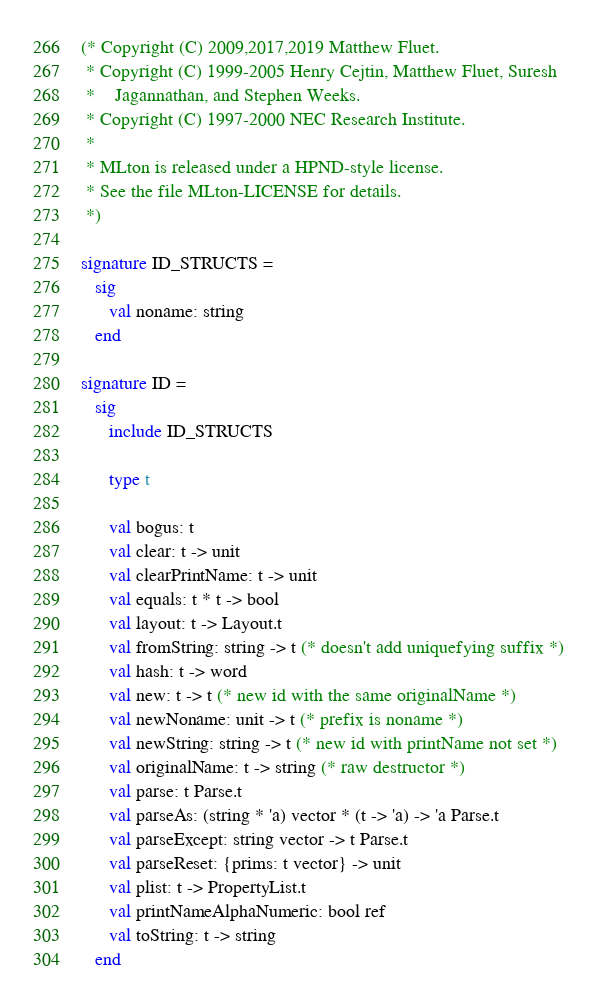<code> <loc_0><loc_0><loc_500><loc_500><_SML_>(* Copyright (C) 2009,2017,2019 Matthew Fluet.
 * Copyright (C) 1999-2005 Henry Cejtin, Matthew Fluet, Suresh
 *    Jagannathan, and Stephen Weeks.
 * Copyright (C) 1997-2000 NEC Research Institute.
 *
 * MLton is released under a HPND-style license.
 * See the file MLton-LICENSE for details.
 *)

signature ID_STRUCTS =
   sig
      val noname: string
   end

signature ID =
   sig
      include ID_STRUCTS

      type t

      val bogus: t
      val clear: t -> unit
      val clearPrintName: t -> unit
      val equals: t * t -> bool
      val layout: t -> Layout.t
      val fromString: string -> t (* doesn't add uniquefying suffix *)
      val hash: t -> word
      val new: t -> t (* new id with the same originalName *)
      val newNoname: unit -> t (* prefix is noname *)
      val newString: string -> t (* new id with printName not set *)
      val originalName: t -> string (* raw destructor *)
      val parse: t Parse.t
      val parseAs: (string * 'a) vector * (t -> 'a) -> 'a Parse.t
      val parseExcept: string vector -> t Parse.t
      val parseReset: {prims: t vector} -> unit
      val plist: t -> PropertyList.t
      val printNameAlphaNumeric: bool ref
      val toString: t -> string
   end
</code> 